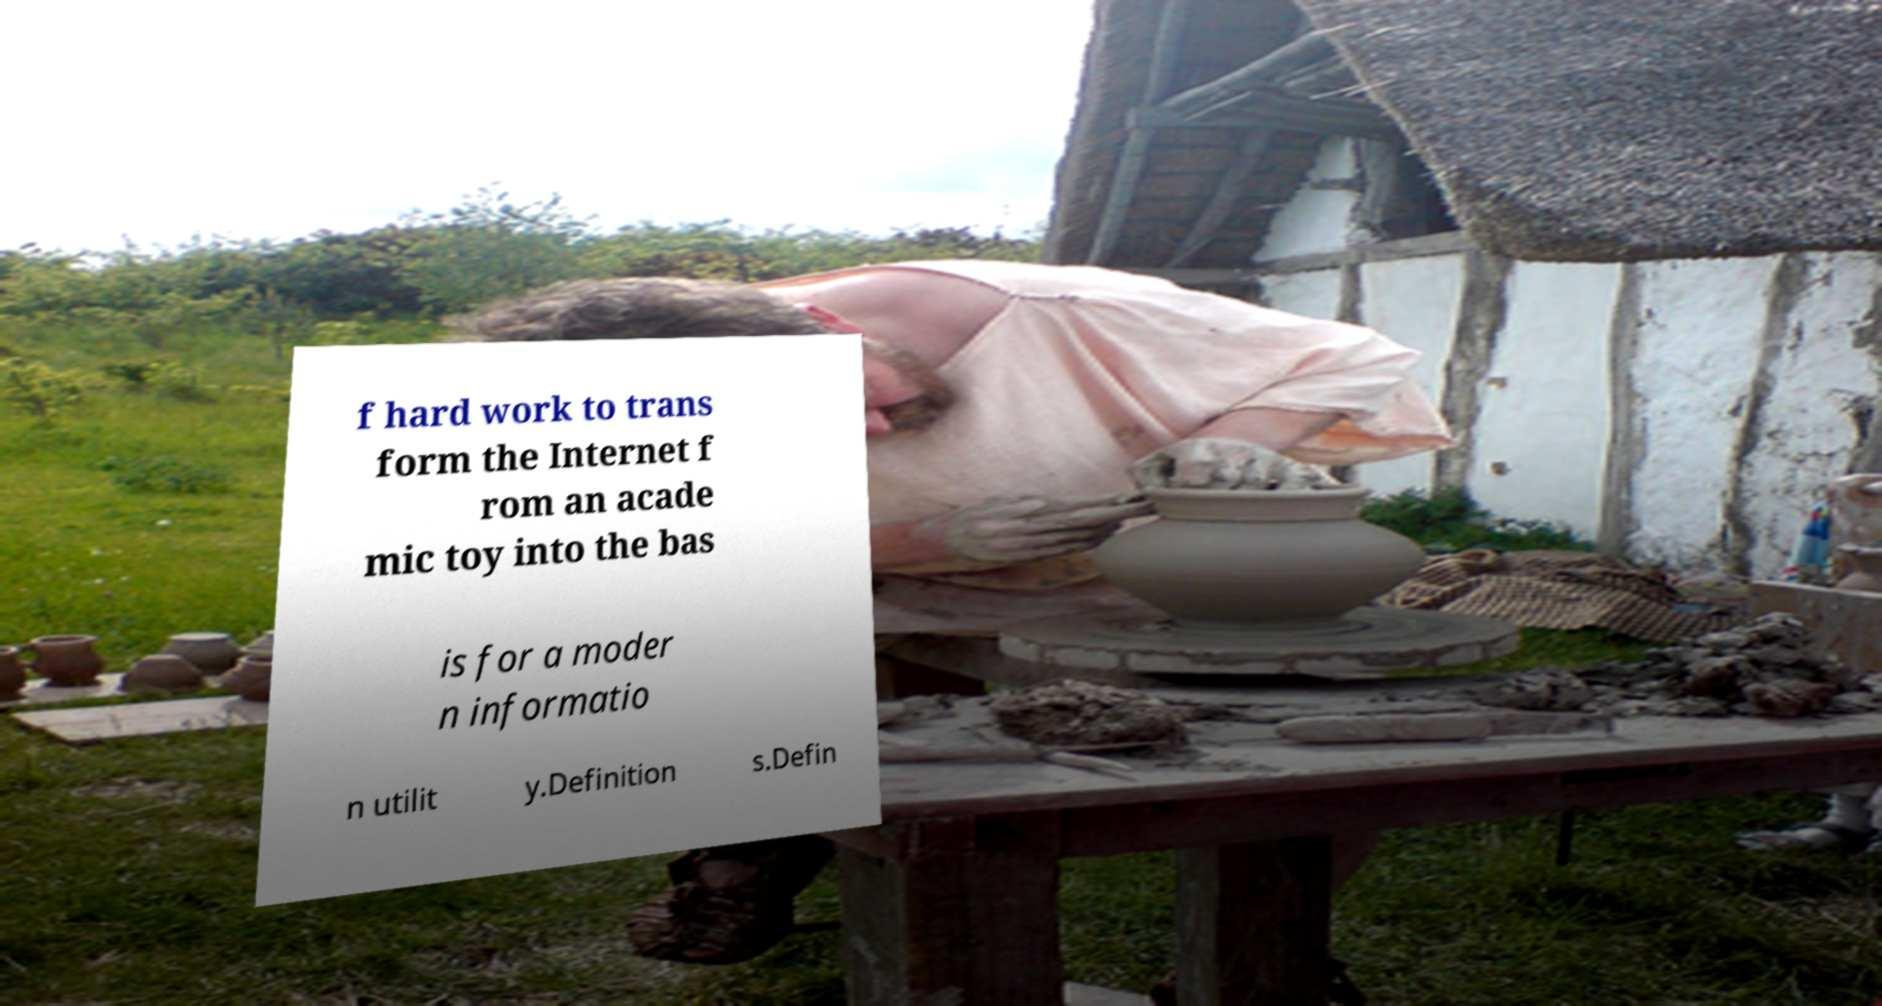What messages or text are displayed in this image? I need them in a readable, typed format. f hard work to trans form the Internet f rom an acade mic toy into the bas is for a moder n informatio n utilit y.Definition s.Defin 